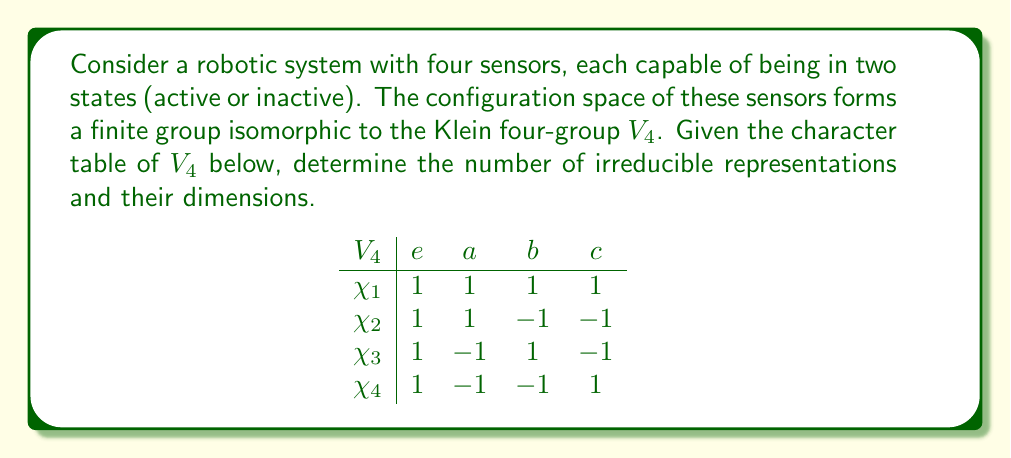Could you help me with this problem? To solve this problem, we'll follow these steps:

1) Recall that the number of irreducible representations of a finite group is equal to the number of conjugacy classes in the group. In the character table, each column represents a conjugacy class.

2) Count the number of columns in the character table:
   There are 4 columns (e, a, b, c), so there are 4 conjugacy classes.

3) The number of irreducible representations is equal to the number of rows in the character table. We can see that there are also 4 rows ($\chi_1$, $\chi_2$, $\chi_3$, $\chi_4$).

4) To determine the dimensions of the irreducible representations, we look at the values in the first column (corresponding to the identity element e). The dimension of each irreducible representation is the value of its character on the identity element.

5) We observe that all values in the first column are 1:
   $\chi_1(e) = \chi_2(e) = \chi_3(e) = \chi_4(e) = 1$

6) This means that all irreducible representations are 1-dimensional.

7) We can verify this using the formula:
   $\sum_{i=1}^{k} d_i^2 = |G|$
   where $k$ is the number of irreducible representations, $d_i$ are their dimensions, and $|G|$ is the order of the group.

   In this case: $1^2 + 1^2 + 1^2 + 1^2 = 4 = |V_4|$

Therefore, the Klein four-group $V_4$, representing the robotic sensor configurations, has 4 irreducible representations, each of dimension 1.
Answer: 4 irreducible representations, all 1-dimensional 